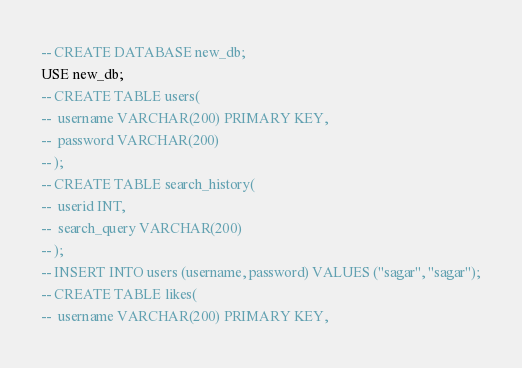<code> <loc_0><loc_0><loc_500><loc_500><_SQL_>-- CREATE DATABASE new_db;
USE new_db;
-- CREATE TABLE users(
-- 	username VARCHAR(200) PRIMARY KEY,
-- 	password VARCHAR(200)
-- );
-- CREATE TABLE search_history(
-- 	userid INT,
-- 	search_query VARCHAR(200)
-- );
-- INSERT INTO users (username, password) VALUES ("sagar", "sagar");
-- CREATE TABLE likes(
-- 	username VARCHAR(200) PRIMARY KEY,</code> 